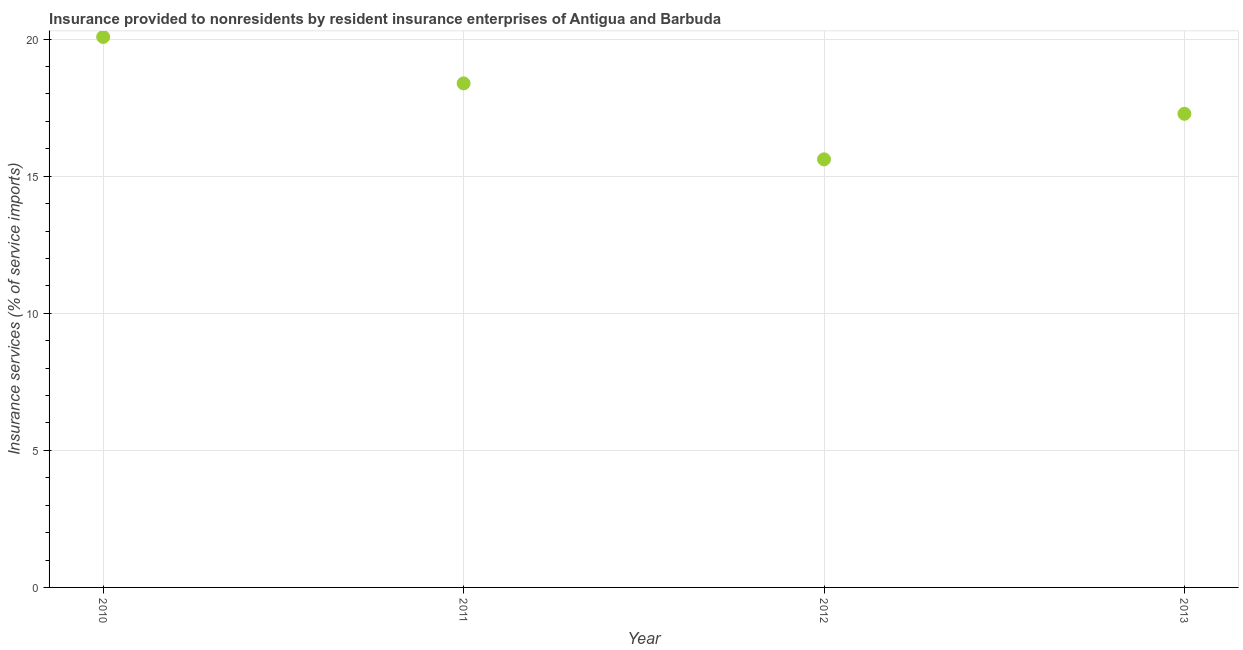What is the insurance and financial services in 2012?
Offer a very short reply. 15.61. Across all years, what is the maximum insurance and financial services?
Give a very brief answer. 20.08. Across all years, what is the minimum insurance and financial services?
Offer a terse response. 15.61. In which year was the insurance and financial services maximum?
Your answer should be very brief. 2010. In which year was the insurance and financial services minimum?
Give a very brief answer. 2012. What is the sum of the insurance and financial services?
Offer a very short reply. 71.35. What is the difference between the insurance and financial services in 2010 and 2011?
Make the answer very short. 1.69. What is the average insurance and financial services per year?
Provide a succinct answer. 17.84. What is the median insurance and financial services?
Give a very brief answer. 17.83. In how many years, is the insurance and financial services greater than 12 %?
Your answer should be very brief. 4. Do a majority of the years between 2013 and 2011 (inclusive) have insurance and financial services greater than 5 %?
Give a very brief answer. No. What is the ratio of the insurance and financial services in 2010 to that in 2012?
Provide a short and direct response. 1.29. Is the insurance and financial services in 2011 less than that in 2013?
Your answer should be very brief. No. Is the difference between the insurance and financial services in 2010 and 2012 greater than the difference between any two years?
Keep it short and to the point. Yes. What is the difference between the highest and the second highest insurance and financial services?
Provide a succinct answer. 1.69. Is the sum of the insurance and financial services in 2010 and 2011 greater than the maximum insurance and financial services across all years?
Provide a succinct answer. Yes. What is the difference between the highest and the lowest insurance and financial services?
Provide a short and direct response. 4.46. What is the title of the graph?
Keep it short and to the point. Insurance provided to nonresidents by resident insurance enterprises of Antigua and Barbuda. What is the label or title of the Y-axis?
Offer a terse response. Insurance services (% of service imports). What is the Insurance services (% of service imports) in 2010?
Make the answer very short. 20.08. What is the Insurance services (% of service imports) in 2011?
Your answer should be compact. 18.38. What is the Insurance services (% of service imports) in 2012?
Give a very brief answer. 15.61. What is the Insurance services (% of service imports) in 2013?
Make the answer very short. 17.28. What is the difference between the Insurance services (% of service imports) in 2010 and 2011?
Your answer should be very brief. 1.69. What is the difference between the Insurance services (% of service imports) in 2010 and 2012?
Give a very brief answer. 4.46. What is the difference between the Insurance services (% of service imports) in 2010 and 2013?
Make the answer very short. 2.8. What is the difference between the Insurance services (% of service imports) in 2011 and 2012?
Your response must be concise. 2.77. What is the difference between the Insurance services (% of service imports) in 2011 and 2013?
Give a very brief answer. 1.11. What is the difference between the Insurance services (% of service imports) in 2012 and 2013?
Offer a very short reply. -1.66. What is the ratio of the Insurance services (% of service imports) in 2010 to that in 2011?
Provide a succinct answer. 1.09. What is the ratio of the Insurance services (% of service imports) in 2010 to that in 2012?
Give a very brief answer. 1.29. What is the ratio of the Insurance services (% of service imports) in 2010 to that in 2013?
Your response must be concise. 1.16. What is the ratio of the Insurance services (% of service imports) in 2011 to that in 2012?
Your response must be concise. 1.18. What is the ratio of the Insurance services (% of service imports) in 2011 to that in 2013?
Your answer should be compact. 1.06. What is the ratio of the Insurance services (% of service imports) in 2012 to that in 2013?
Provide a short and direct response. 0.9. 